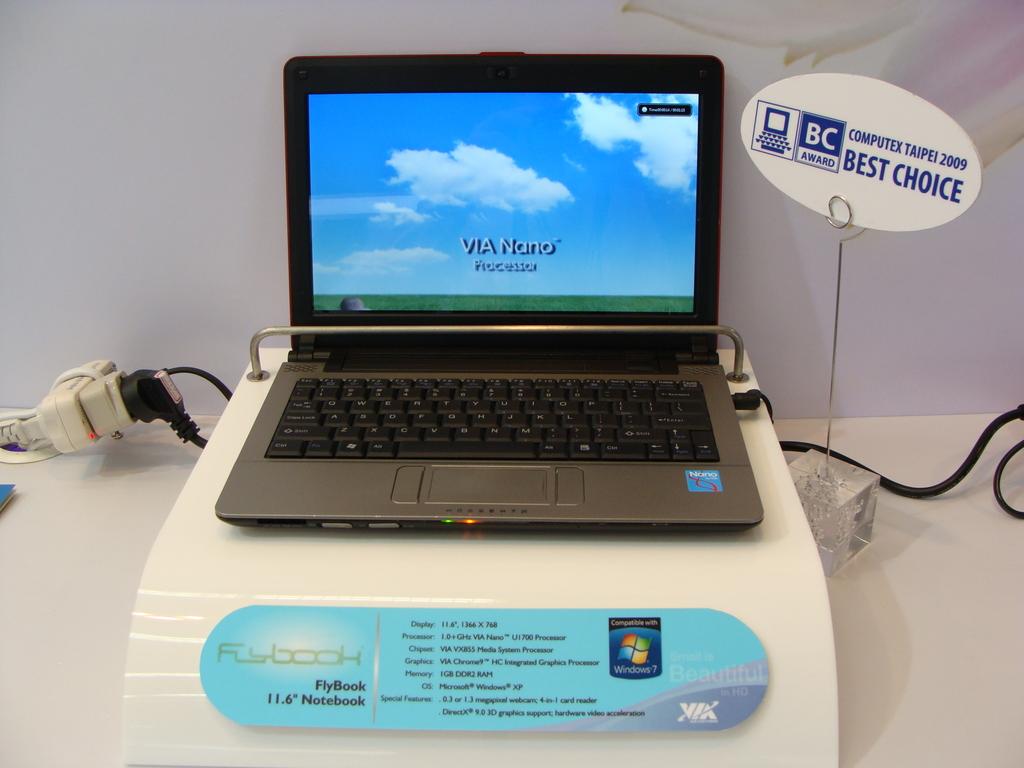What is the screen size in inches?
Keep it short and to the point. 11.6. Is the computex taipei 2009 the best choice?
Give a very brief answer. Yes. 